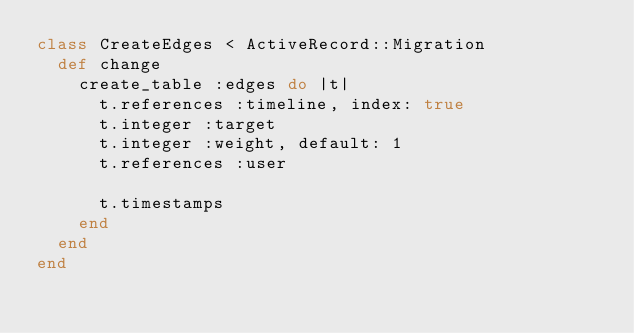Convert code to text. <code><loc_0><loc_0><loc_500><loc_500><_Ruby_>class CreateEdges < ActiveRecord::Migration
  def change
    create_table :edges do |t|
      t.references :timeline, index: true
      t.integer :target
      t.integer :weight, default: 1
      t.references :user

      t.timestamps
    end
  end
end
</code> 